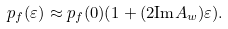<formula> <loc_0><loc_0><loc_500><loc_500>p _ { f } ( \varepsilon ) & \approx p _ { f } ( 0 ) ( 1 + ( 2 \text {Im} A _ { w } ) \varepsilon ) .</formula> 